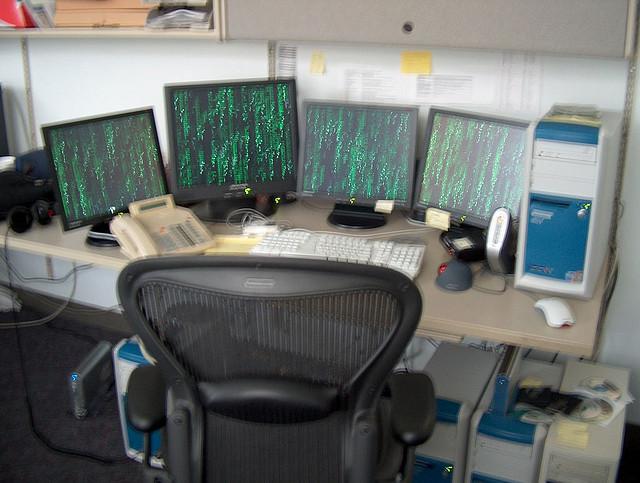How many monitors are on the desk?
Concise answer only. 4. How many computers are there?
Quick response, please. 4. What colors are on the screen?
Be succinct. Green. How many monitors are there?
Concise answer only. 4. 